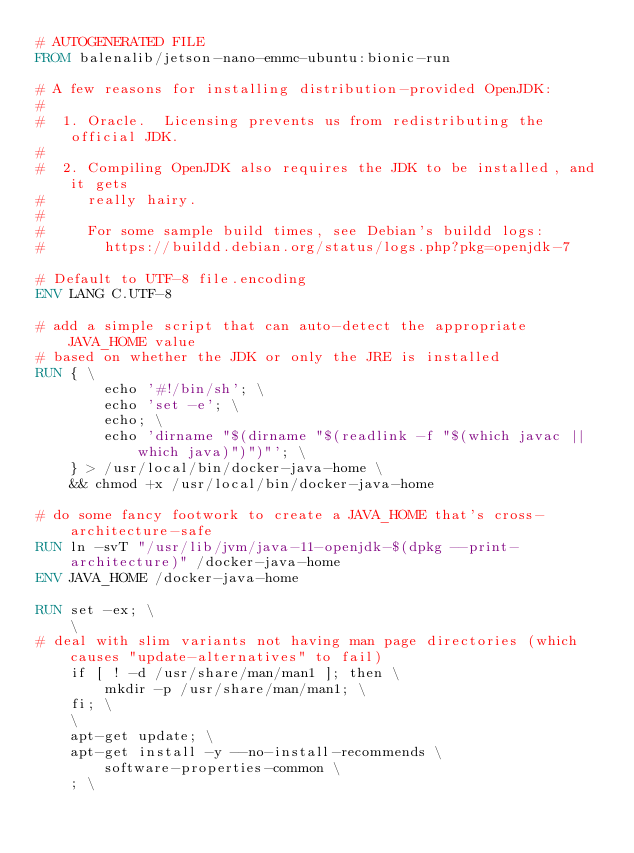<code> <loc_0><loc_0><loc_500><loc_500><_Dockerfile_># AUTOGENERATED FILE
FROM balenalib/jetson-nano-emmc-ubuntu:bionic-run

# A few reasons for installing distribution-provided OpenJDK:
#
#  1. Oracle.  Licensing prevents us from redistributing the official JDK.
#
#  2. Compiling OpenJDK also requires the JDK to be installed, and it gets
#     really hairy.
#
#     For some sample build times, see Debian's buildd logs:
#       https://buildd.debian.org/status/logs.php?pkg=openjdk-7

# Default to UTF-8 file.encoding
ENV LANG C.UTF-8

# add a simple script that can auto-detect the appropriate JAVA_HOME value
# based on whether the JDK or only the JRE is installed
RUN { \
		echo '#!/bin/sh'; \
		echo 'set -e'; \
		echo; \
		echo 'dirname "$(dirname "$(readlink -f "$(which javac || which java)")")"'; \
	} > /usr/local/bin/docker-java-home \
	&& chmod +x /usr/local/bin/docker-java-home

# do some fancy footwork to create a JAVA_HOME that's cross-architecture-safe
RUN ln -svT "/usr/lib/jvm/java-11-openjdk-$(dpkg --print-architecture)" /docker-java-home
ENV JAVA_HOME /docker-java-home

RUN set -ex; \
	\
# deal with slim variants not having man page directories (which causes "update-alternatives" to fail)
	if [ ! -d /usr/share/man/man1 ]; then \
		mkdir -p /usr/share/man/man1; \
	fi; \
	\
	apt-get update; \
	apt-get install -y --no-install-recommends \
		software-properties-common \
	; \</code> 